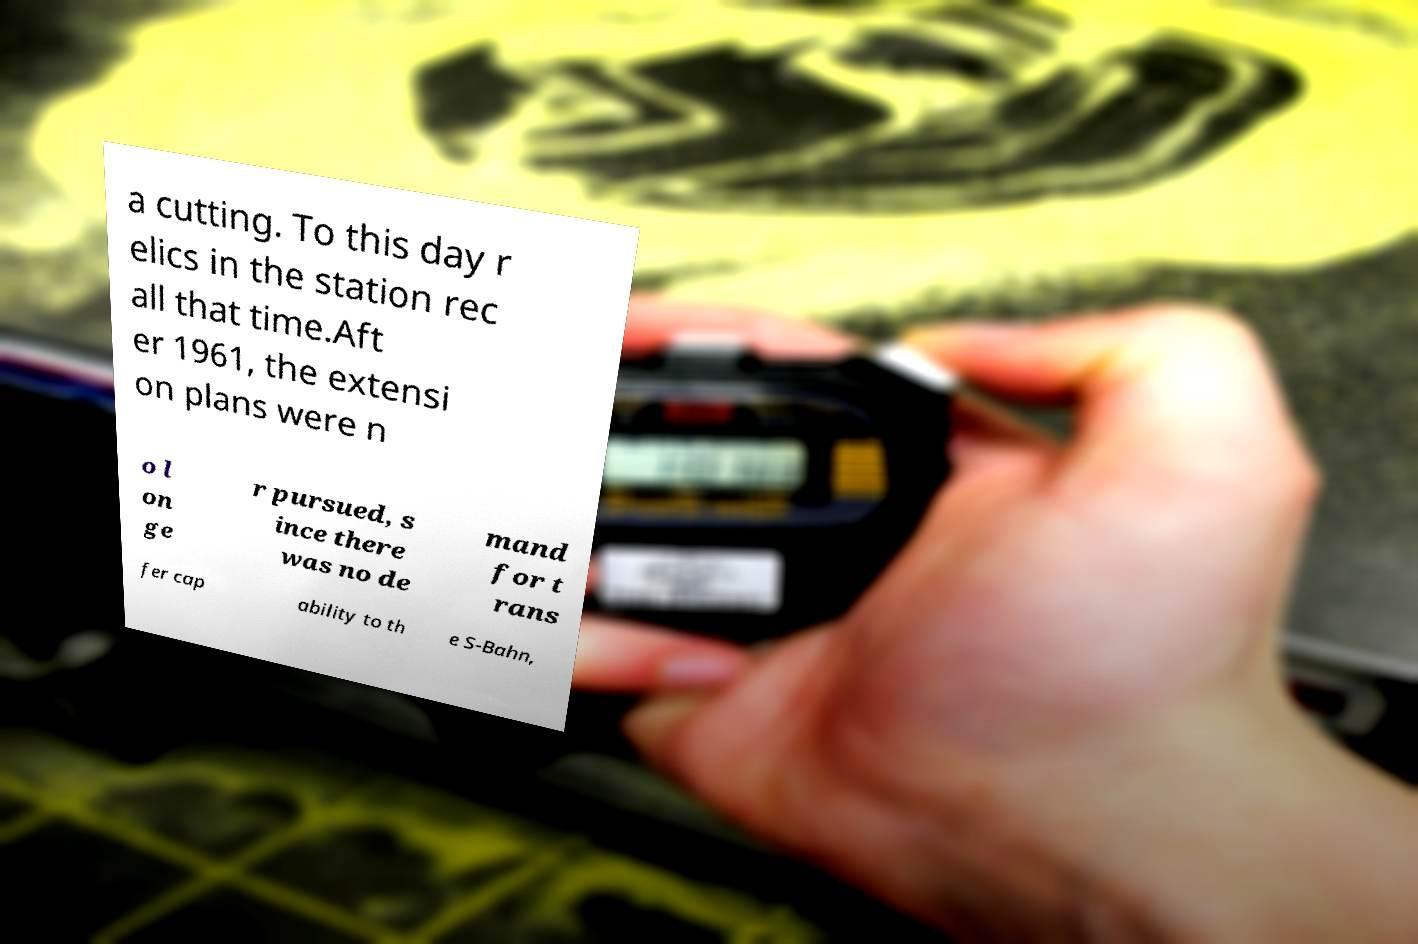Please read and relay the text visible in this image. What does it say? a cutting. To this day r elics in the station rec all that time.Aft er 1961, the extensi on plans were n o l on ge r pursued, s ince there was no de mand for t rans fer cap ability to th e S-Bahn, 